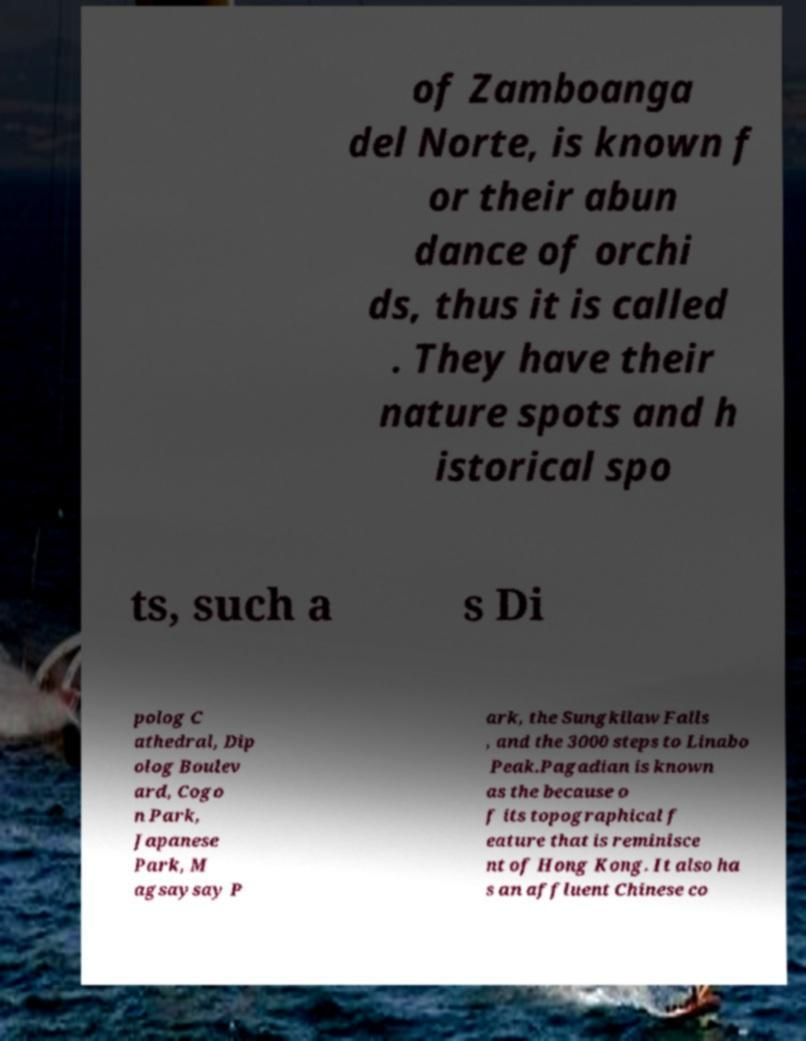Please identify and transcribe the text found in this image. of Zamboanga del Norte, is known f or their abun dance of orchi ds, thus it is called . They have their nature spots and h istorical spo ts, such a s Di polog C athedral, Dip olog Boulev ard, Cogo n Park, Japanese Park, M agsaysay P ark, the Sungkilaw Falls , and the 3000 steps to Linabo Peak.Pagadian is known as the because o f its topographical f eature that is reminisce nt of Hong Kong. It also ha s an affluent Chinese co 